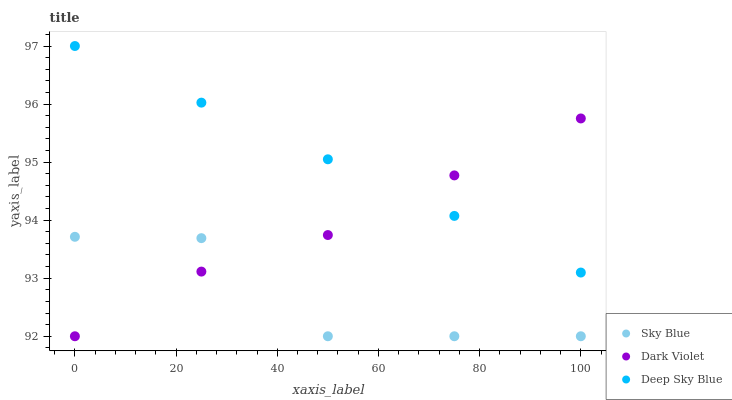Does Sky Blue have the minimum area under the curve?
Answer yes or no. Yes. Does Deep Sky Blue have the maximum area under the curve?
Answer yes or no. Yes. Does Dark Violet have the minimum area under the curve?
Answer yes or no. No. Does Dark Violet have the maximum area under the curve?
Answer yes or no. No. Is Deep Sky Blue the smoothest?
Answer yes or no. Yes. Is Sky Blue the roughest?
Answer yes or no. Yes. Is Dark Violet the smoothest?
Answer yes or no. No. Is Dark Violet the roughest?
Answer yes or no. No. Does Sky Blue have the lowest value?
Answer yes or no. Yes. Does Deep Sky Blue have the lowest value?
Answer yes or no. No. Does Deep Sky Blue have the highest value?
Answer yes or no. Yes. Does Dark Violet have the highest value?
Answer yes or no. No. Is Sky Blue less than Deep Sky Blue?
Answer yes or no. Yes. Is Deep Sky Blue greater than Sky Blue?
Answer yes or no. Yes. Does Dark Violet intersect Sky Blue?
Answer yes or no. Yes. Is Dark Violet less than Sky Blue?
Answer yes or no. No. Is Dark Violet greater than Sky Blue?
Answer yes or no. No. Does Sky Blue intersect Deep Sky Blue?
Answer yes or no. No. 